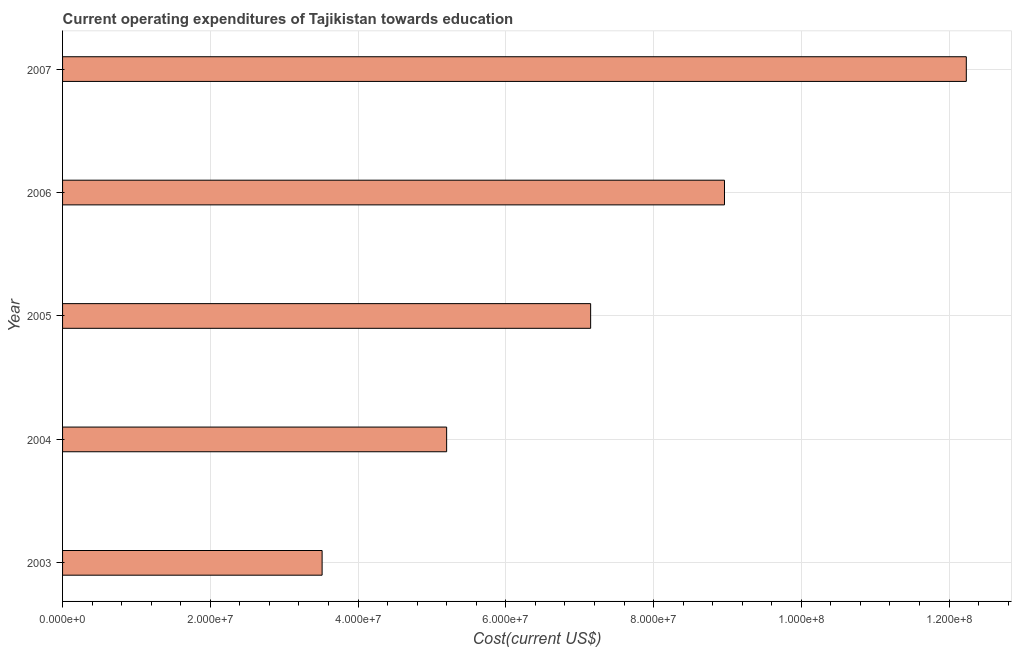Does the graph contain grids?
Your answer should be compact. Yes. What is the title of the graph?
Your response must be concise. Current operating expenditures of Tajikistan towards education. What is the label or title of the X-axis?
Your answer should be very brief. Cost(current US$). What is the label or title of the Y-axis?
Offer a terse response. Year. What is the education expenditure in 2006?
Give a very brief answer. 8.96e+07. Across all years, what is the maximum education expenditure?
Ensure brevity in your answer.  1.22e+08. Across all years, what is the minimum education expenditure?
Keep it short and to the point. 3.51e+07. In which year was the education expenditure maximum?
Offer a very short reply. 2007. In which year was the education expenditure minimum?
Your answer should be compact. 2003. What is the sum of the education expenditure?
Keep it short and to the point. 3.71e+08. What is the difference between the education expenditure in 2004 and 2006?
Your answer should be very brief. -3.76e+07. What is the average education expenditure per year?
Give a very brief answer. 7.41e+07. What is the median education expenditure?
Give a very brief answer. 7.15e+07. What is the ratio of the education expenditure in 2005 to that in 2007?
Ensure brevity in your answer.  0.58. What is the difference between the highest and the second highest education expenditure?
Offer a very short reply. 3.27e+07. What is the difference between the highest and the lowest education expenditure?
Provide a succinct answer. 8.72e+07. How many bars are there?
Offer a terse response. 5. Are all the bars in the graph horizontal?
Offer a terse response. Yes. How many years are there in the graph?
Offer a very short reply. 5. What is the Cost(current US$) of 2003?
Offer a very short reply. 3.51e+07. What is the Cost(current US$) in 2004?
Offer a very short reply. 5.20e+07. What is the Cost(current US$) in 2005?
Your answer should be very brief. 7.15e+07. What is the Cost(current US$) in 2006?
Make the answer very short. 8.96e+07. What is the Cost(current US$) of 2007?
Your response must be concise. 1.22e+08. What is the difference between the Cost(current US$) in 2003 and 2004?
Offer a terse response. -1.69e+07. What is the difference between the Cost(current US$) in 2003 and 2005?
Provide a succinct answer. -3.63e+07. What is the difference between the Cost(current US$) in 2003 and 2006?
Your response must be concise. -5.45e+07. What is the difference between the Cost(current US$) in 2003 and 2007?
Your answer should be compact. -8.72e+07. What is the difference between the Cost(current US$) in 2004 and 2005?
Make the answer very short. -1.95e+07. What is the difference between the Cost(current US$) in 2004 and 2006?
Your answer should be very brief. -3.76e+07. What is the difference between the Cost(current US$) in 2004 and 2007?
Give a very brief answer. -7.03e+07. What is the difference between the Cost(current US$) in 2005 and 2006?
Make the answer very short. -1.81e+07. What is the difference between the Cost(current US$) in 2005 and 2007?
Give a very brief answer. -5.09e+07. What is the difference between the Cost(current US$) in 2006 and 2007?
Offer a terse response. -3.27e+07. What is the ratio of the Cost(current US$) in 2003 to that in 2004?
Ensure brevity in your answer.  0.68. What is the ratio of the Cost(current US$) in 2003 to that in 2005?
Give a very brief answer. 0.49. What is the ratio of the Cost(current US$) in 2003 to that in 2006?
Your response must be concise. 0.39. What is the ratio of the Cost(current US$) in 2003 to that in 2007?
Provide a short and direct response. 0.29. What is the ratio of the Cost(current US$) in 2004 to that in 2005?
Provide a succinct answer. 0.73. What is the ratio of the Cost(current US$) in 2004 to that in 2006?
Provide a succinct answer. 0.58. What is the ratio of the Cost(current US$) in 2004 to that in 2007?
Keep it short and to the point. 0.42. What is the ratio of the Cost(current US$) in 2005 to that in 2006?
Make the answer very short. 0.8. What is the ratio of the Cost(current US$) in 2005 to that in 2007?
Offer a terse response. 0.58. What is the ratio of the Cost(current US$) in 2006 to that in 2007?
Offer a terse response. 0.73. 